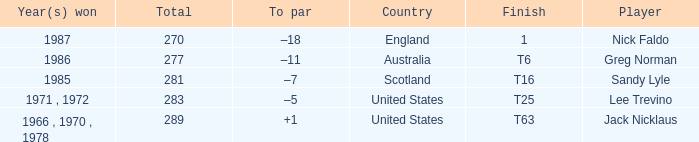What player has 289 as the total? Jack Nicklaus. 